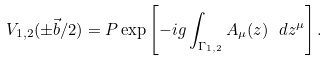<formula> <loc_0><loc_0><loc_500><loc_500>V _ { 1 , 2 } ( \pm \vec { b } / 2 ) = { P } \exp \left [ - i g \int _ { \Gamma _ { 1 , 2 } } { A } _ { \mu } ( z ) \ d z ^ { \mu } \right ] .</formula> 